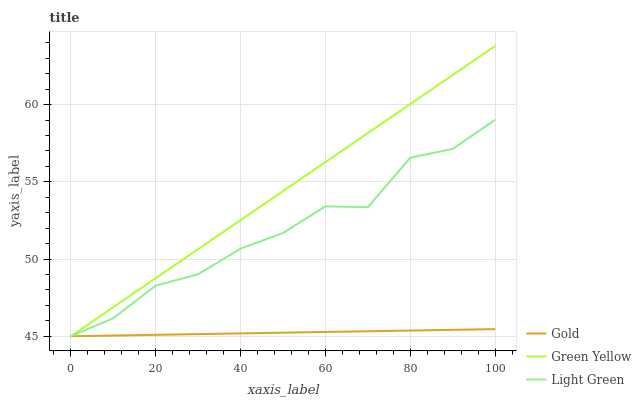Does Gold have the minimum area under the curve?
Answer yes or no. Yes. Does Green Yellow have the maximum area under the curve?
Answer yes or no. Yes. Does Light Green have the minimum area under the curve?
Answer yes or no. No. Does Light Green have the maximum area under the curve?
Answer yes or no. No. Is Gold the smoothest?
Answer yes or no. Yes. Is Light Green the roughest?
Answer yes or no. Yes. Is Light Green the smoothest?
Answer yes or no. No. Is Gold the roughest?
Answer yes or no. No. Does Green Yellow have the lowest value?
Answer yes or no. Yes. Does Green Yellow have the highest value?
Answer yes or no. Yes. Does Light Green have the highest value?
Answer yes or no. No. Does Green Yellow intersect Light Green?
Answer yes or no. Yes. Is Green Yellow less than Light Green?
Answer yes or no. No. Is Green Yellow greater than Light Green?
Answer yes or no. No. 